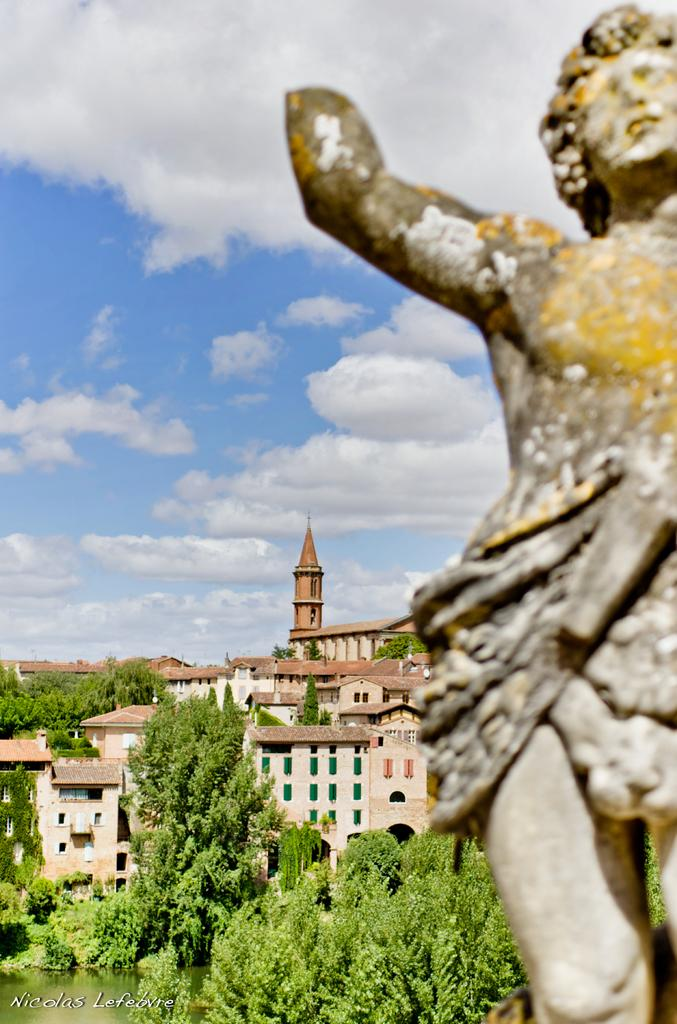What is located on the right side of the image? There is a statue on the right side of the image. What type of structures can be seen in the image? There are buildings in the image. What other natural elements are present in the image? There are trees in the image. What can be seen in the background of the image? The sky is visible in the background of the image, and there are clouds in the sky. How many boys are participating in the voyage depicted in the image? There is no voyage or boys present in the image; it features a statue, buildings, trees, and a sky with clouds. 